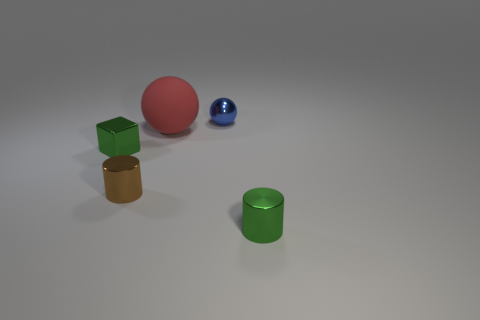Add 2 big spheres. How many objects exist? 7 Subtract all brown cylinders. How many cylinders are left? 1 Subtract 1 cylinders. How many cylinders are left? 1 Add 5 brown metal cylinders. How many brown metal cylinders are left? 6 Add 3 big gray metal cubes. How many big gray metal cubes exist? 3 Subtract 0 purple blocks. How many objects are left? 5 Subtract all cylinders. How many objects are left? 3 Subtract all brown cylinders. Subtract all red spheres. How many cylinders are left? 1 Subtract all red blocks. How many purple cylinders are left? 0 Subtract all big cyan metal balls. Subtract all blue objects. How many objects are left? 4 